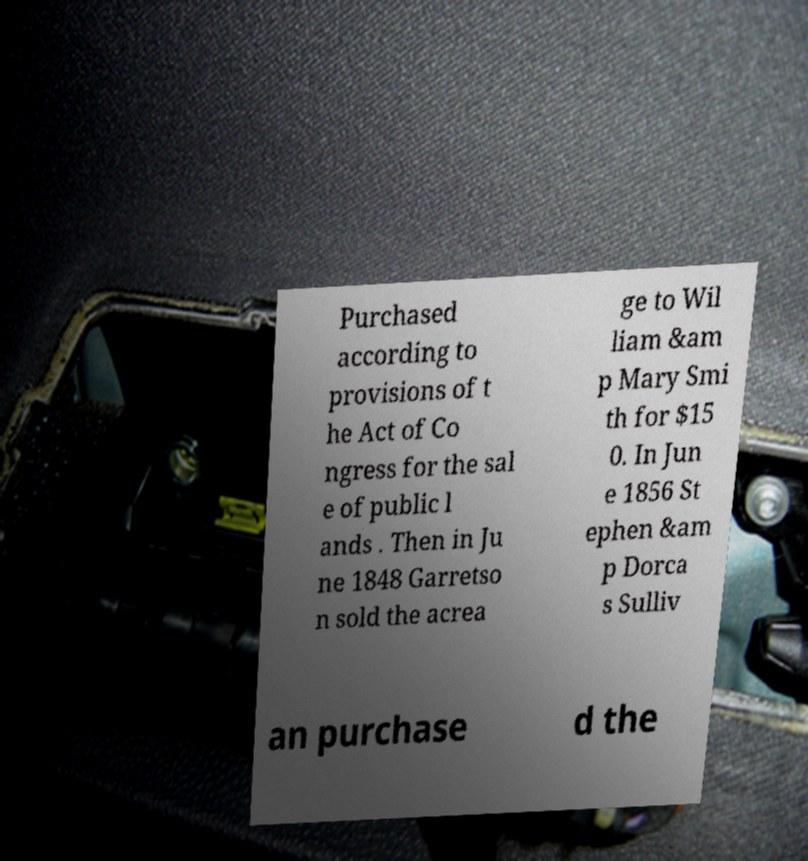What messages or text are displayed in this image? I need them in a readable, typed format. Purchased according to provisions of t he Act of Co ngress for the sal e of public l ands . Then in Ju ne 1848 Garretso n sold the acrea ge to Wil liam &am p Mary Smi th for $15 0. In Jun e 1856 St ephen &am p Dorca s Sulliv an purchase d the 